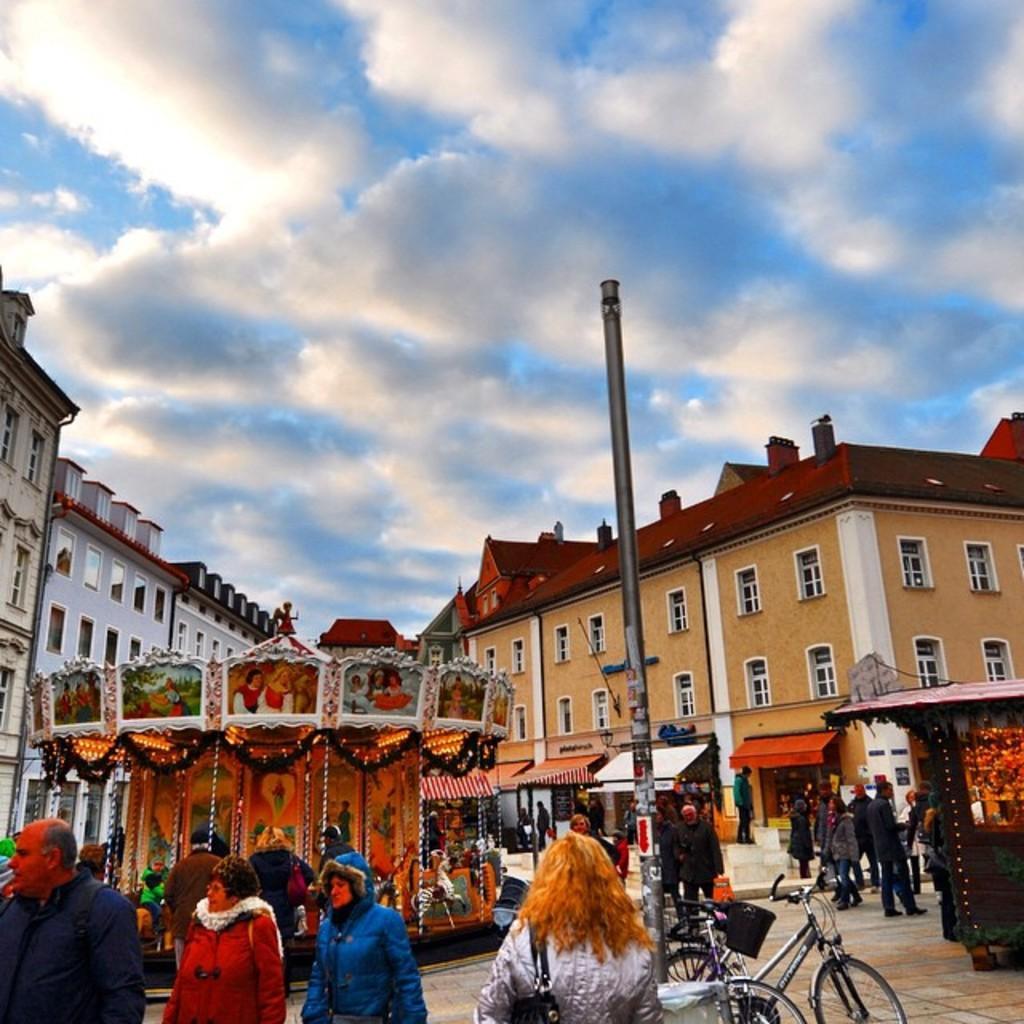In one or two sentences, can you explain what this image depicts? This is a street view. I can see buildings, stalls in the center of the image. I can see a pole, some bicycles, some people walking and standing at the bottom of the image. At the top of the image I can see the sky. 